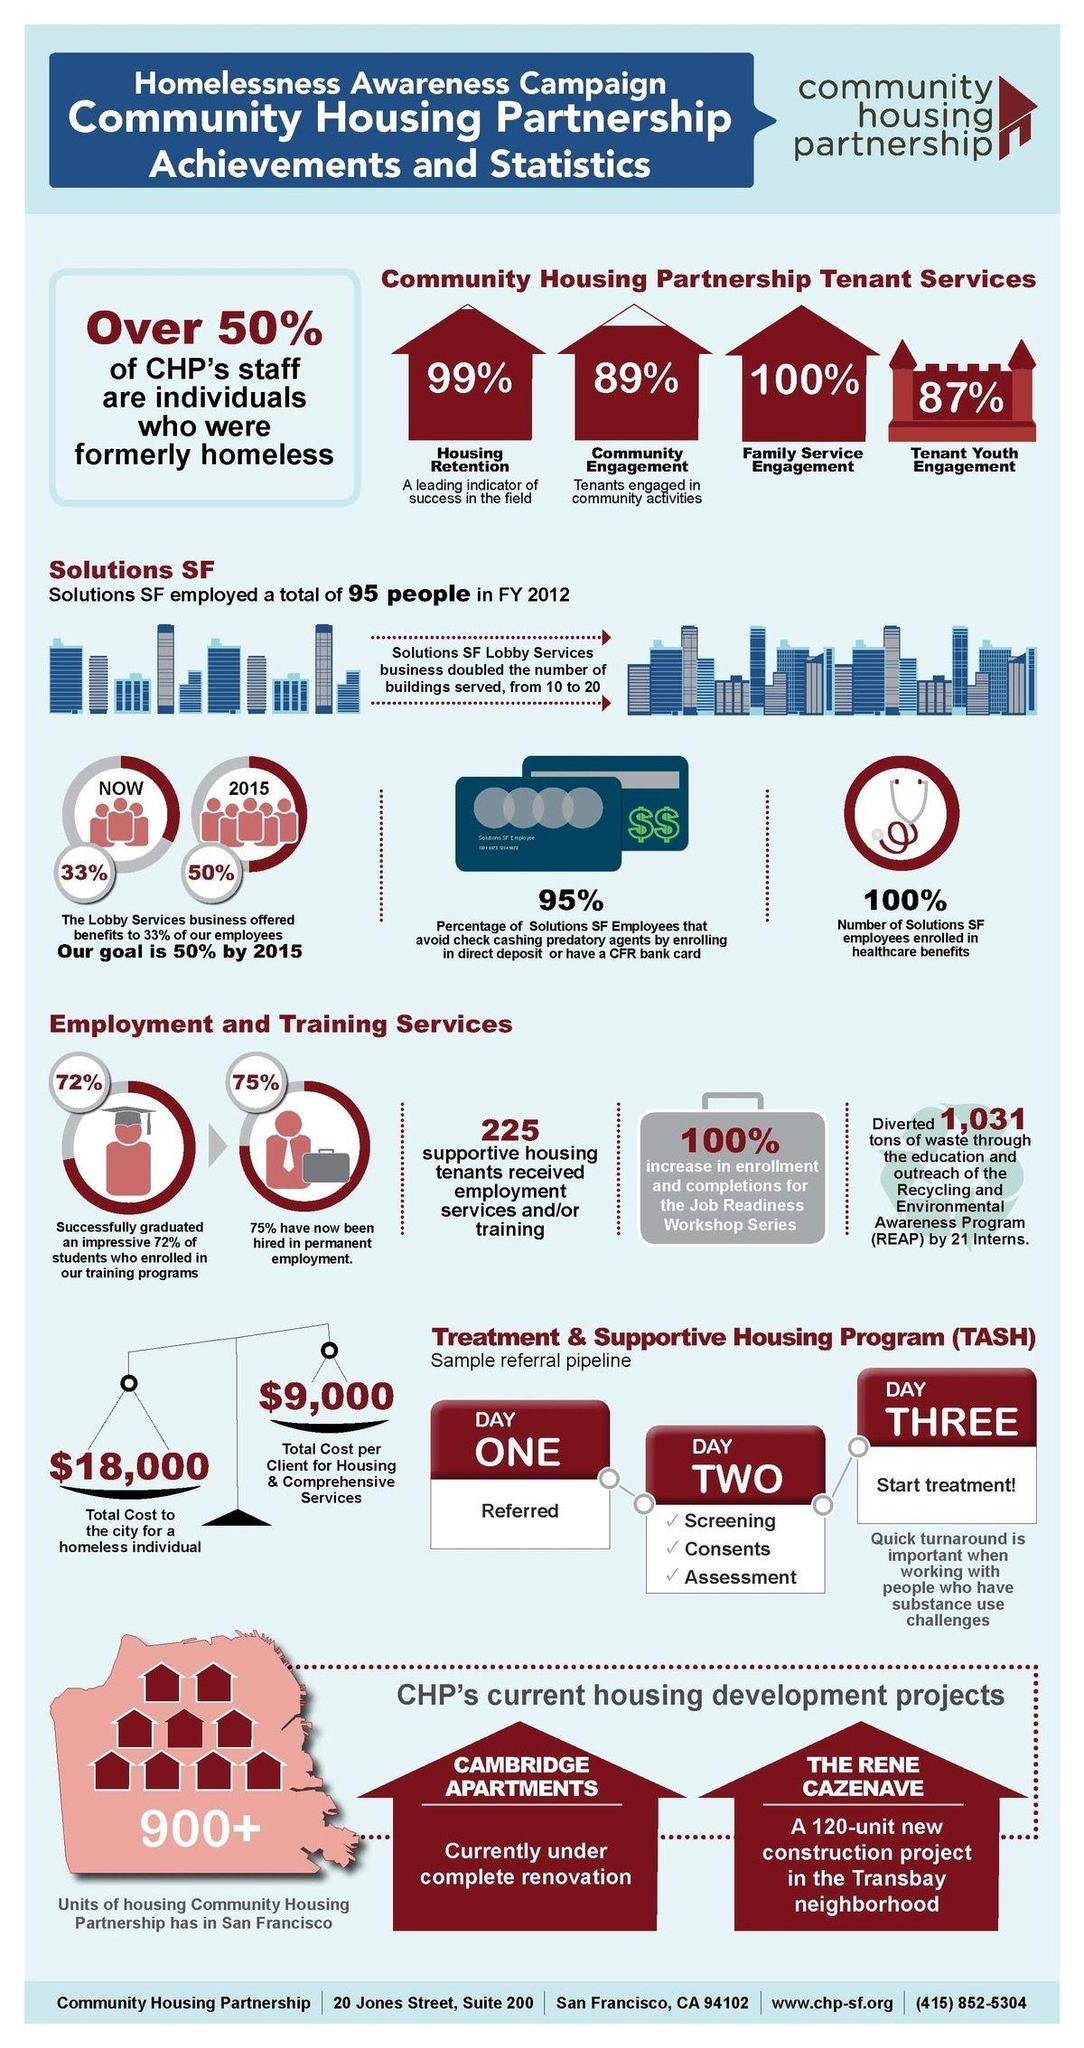List a handful of essential elements in this visual. According to CHP's tenant services, a significant 89% of their services are dedicated to community engagement. Thirty-three percent of the lobby services business now offers benefits to its employees. All of CHP's tenant services are dedicated to family service engagement, at 100%. Community Housing Partnership in San Francisco has more than 900 units. The percentage increase in enrollment and completions for the job readiness workshop series was 100%. 